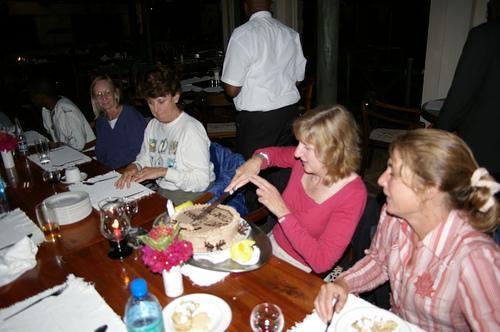How many people are at each table?
Give a very brief answer. 5. How many people are at the table?
Give a very brief answer. 5. How many girls are in the image?
Give a very brief answer. 4. How many people are in the photo?
Give a very brief answer. 6. How many people can be seen?
Give a very brief answer. 7. How many blue cars are in the picture?
Give a very brief answer. 0. 